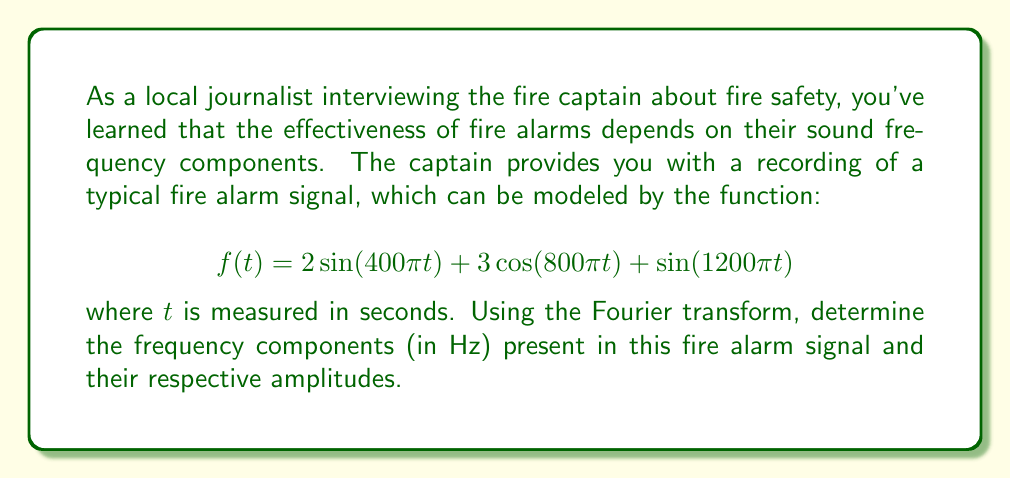Show me your answer to this math problem. To determine the frequency components and their amplitudes, we need to analyze the given function using the Fourier transform. Let's break this down step-by-step:

1) The general form of a sinusoidal function is $A\sin(2\pi ft)$ or $A\cos(2\pi ft)$, where $f$ is the frequency in Hz and $A$ is the amplitude.

2) For the first term, $2\sin(400\pi t)$:
   $400\pi = 2\pi f$
   $f = 200$ Hz
   Amplitude = 2

3) For the second term, $3\cos(800\pi t)$:
   $800\pi = 2\pi f$
   $f = 400$ Hz
   Amplitude = 3

4) For the third term, $\sin(1200\pi t)$:
   $1200\pi = 2\pi f$
   $f = 600$ Hz
   Amplitude = 1

5) The Fourier transform of this signal would have peaks at these frequencies with heights proportional to their amplitudes.

It's worth noting that in real-world applications, fire alarm sounds often use these multiple frequency components to ensure they're audible across a wide range of hearing abilities and to cut through background noise effectively.
Answer: The fire alarm signal contains three frequency components:
1) 200 Hz with amplitude 2
2) 400 Hz with amplitude 3
3) 600 Hz with amplitude 1 